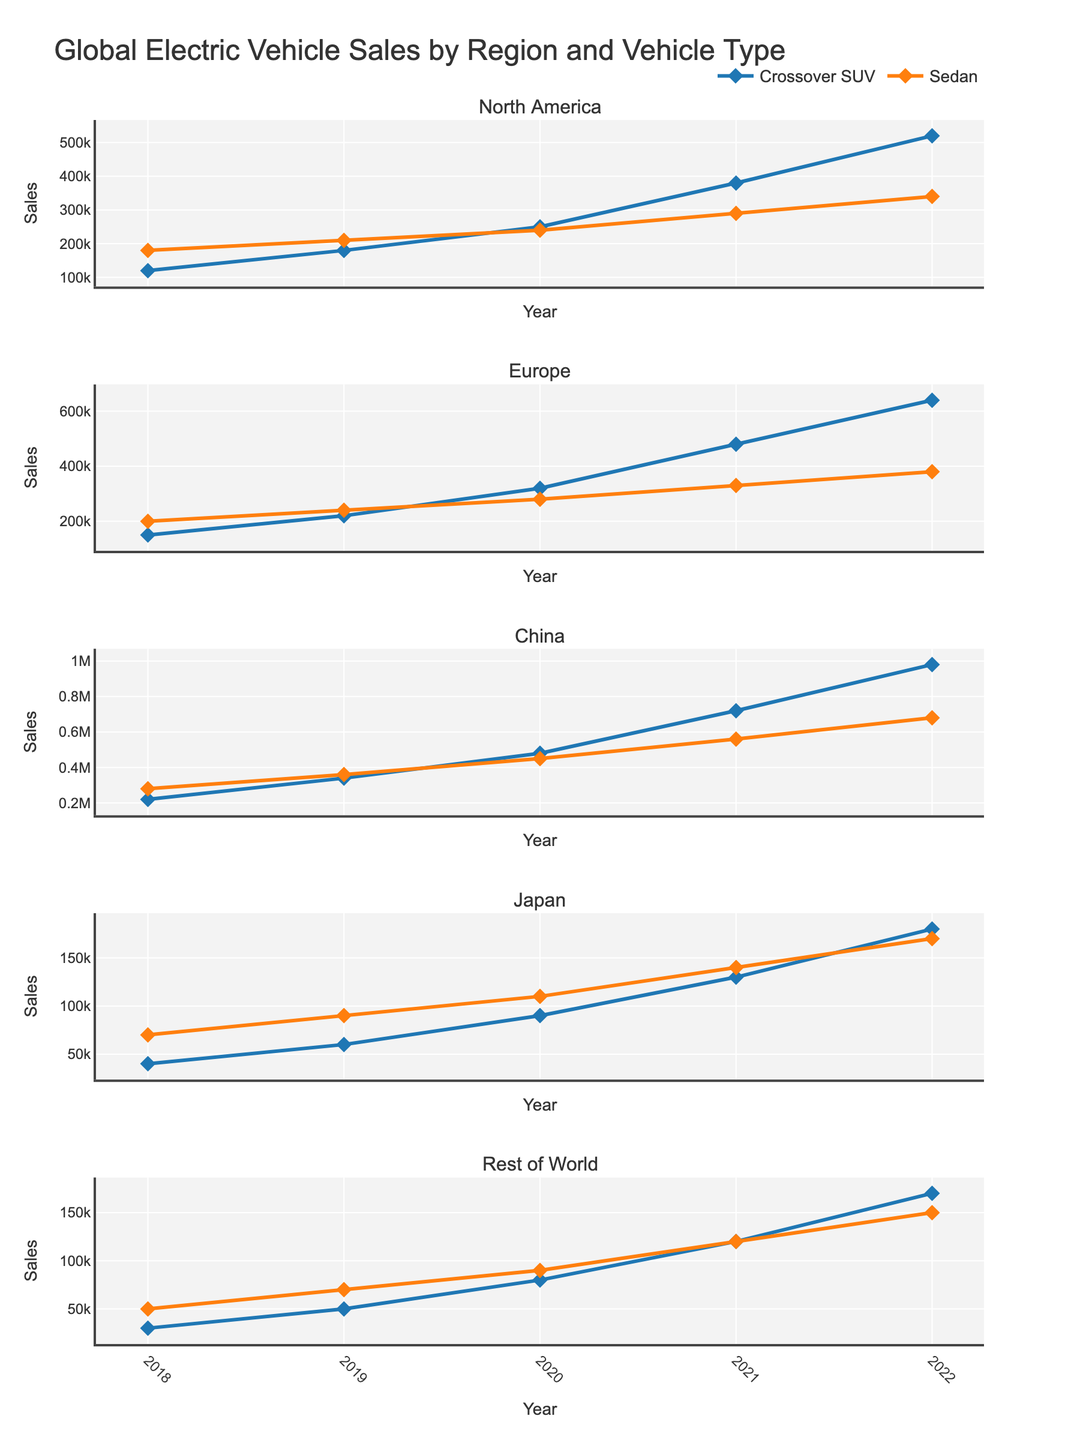What is the general title of the grids of subplots? The title is located at the top of the figure and provides an overview of the content. It reads "Global Electric Vehicle Sales by Region and Vehicle Type" which indicates the focus is on electric vehicle sales data categorized by region and type of vehicle.
Answer: Global Electric Vehicle Sales by Region and Vehicle Type In which region did Crossover SUV sales see the highest growth between 2018 and 2022? By referring to the Crossover SUV sales in each region, you can observe that China starts at 220,000 in 2018 and reaches 980,000 in 2022, showing the largest numerical increase compared to other regions' growth.
Answer: China Which vehicle type had higher sales in North America in 2020, Crossover SUVs or Sedans? Look at the 2020 data points for North America; Crossover SUVs had 250,000 sales while Sedans had 240,000 sales.
Answer: Crossover SUVs What was the total number of Sedans sold in Europe from 2018 to 2022? Sum the yearly sales of Sedans in Europe for each year from 2018 to 2022: 200,000 + 240,000 + 280,000 + 330,000 + 380,000 = 1,430,000.
Answer: 1,430,000 Comparing Crossover SUV sales in Japan and Rest of World in 2021, which was higher? Check the 2021 data points for both regions: Japan had 130,000 sales while Rest of World had 120,000 sales.
Answer: Japan How did European Crossover SUV sales in 2019 compare to those in 2022? In Europe, Crossover SUV sales were 220,000 in 2019 and 640,000 in 2022. To compare, you see that 2022 sales are higher and can calculate the difference if needed (640,000 - 220,000 = 420,000).
Answer: 420,000 more in 2022 What trend can you observe for Sedan sales across all regions from 2018 to 2022? Examine the sales lines for Sedans in each region: they all show a generally increasing trend over the five years, with some regions experiencing more significant growth than others.
Answer: Increasing Trend Which year marks the beginning of more rapid growth for Crossover SUV sales in China? The Crossover SUV sales in China start at 220,000 in 2018 and show a steep rise by 2020 with substantial increments each following year. The rapid growth noticeably begins around 2020.
Answer: 2020 What was the difference in Crossover SUV sales between Europe and Japan in 2022? The sales for Crossover SUVs in Europe and Japan for 2022 can be observed as 640,000 and 180,000, respectively. The difference is 640,000 - 180,000 = 460,000.
Answer: 460,000 Which region had the lowest Sedan sales in 2019? By comparing the 2019 data points for Sedans in all regions, Japan holds the lowest figure at 90,000.
Answer: Japan 